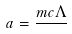<formula> <loc_0><loc_0><loc_500><loc_500>a = \frac { m c \Lambda } { }</formula> 